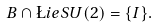Convert formula to latex. <formula><loc_0><loc_0><loc_500><loc_500>B \cap \L i e S U ( 2 ) = \{ I \} .</formula> 